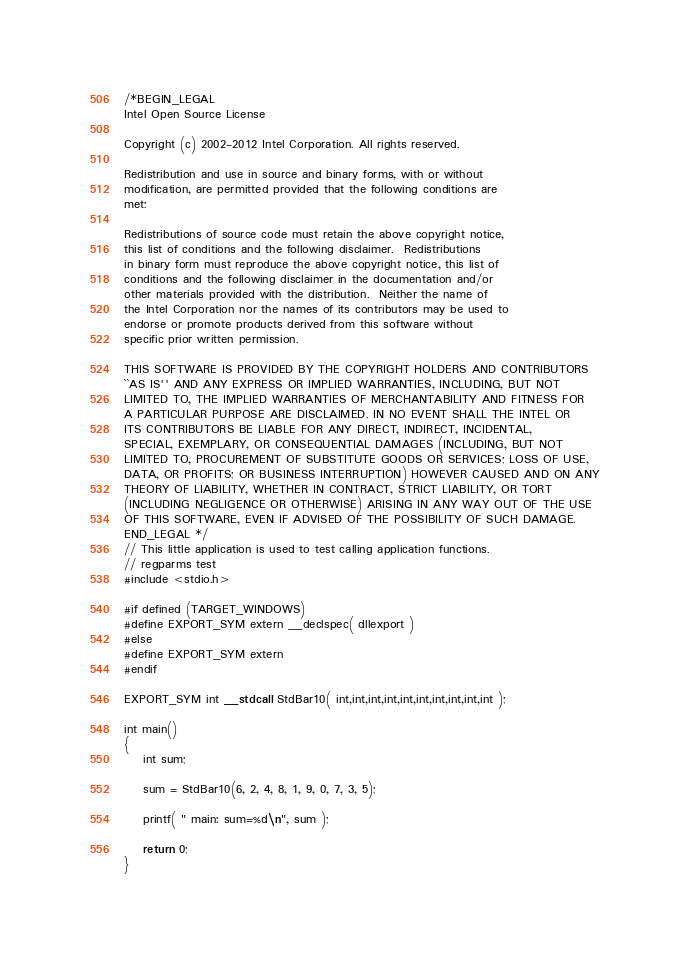Convert code to text. <code><loc_0><loc_0><loc_500><loc_500><_C_>/*BEGIN_LEGAL 
Intel Open Source License 

Copyright (c) 2002-2012 Intel Corporation. All rights reserved.
 
Redistribution and use in source and binary forms, with or without
modification, are permitted provided that the following conditions are
met:

Redistributions of source code must retain the above copyright notice,
this list of conditions and the following disclaimer.  Redistributions
in binary form must reproduce the above copyright notice, this list of
conditions and the following disclaimer in the documentation and/or
other materials provided with the distribution.  Neither the name of
the Intel Corporation nor the names of its contributors may be used to
endorse or promote products derived from this software without
specific prior written permission.
 
THIS SOFTWARE IS PROVIDED BY THE COPYRIGHT HOLDERS AND CONTRIBUTORS
``AS IS'' AND ANY EXPRESS OR IMPLIED WARRANTIES, INCLUDING, BUT NOT
LIMITED TO, THE IMPLIED WARRANTIES OF MERCHANTABILITY AND FITNESS FOR
A PARTICULAR PURPOSE ARE DISCLAIMED. IN NO EVENT SHALL THE INTEL OR
ITS CONTRIBUTORS BE LIABLE FOR ANY DIRECT, INDIRECT, INCIDENTAL,
SPECIAL, EXEMPLARY, OR CONSEQUENTIAL DAMAGES (INCLUDING, BUT NOT
LIMITED TO, PROCUREMENT OF SUBSTITUTE GOODS OR SERVICES; LOSS OF USE,
DATA, OR PROFITS; OR BUSINESS INTERRUPTION) HOWEVER CAUSED AND ON ANY
THEORY OF LIABILITY, WHETHER IN CONTRACT, STRICT LIABILITY, OR TORT
(INCLUDING NEGLIGENCE OR OTHERWISE) ARISING IN ANY WAY OUT OF THE USE
OF THIS SOFTWARE, EVEN IF ADVISED OF THE POSSIBILITY OF SUCH DAMAGE.
END_LEGAL */
// This little application is used to test calling application functions.
// regparms test
#include <stdio.h>

#if defined (TARGET_WINDOWS)
#define EXPORT_SYM extern __declspec( dllexport ) 
#else
#define EXPORT_SYM extern
#endif

EXPORT_SYM int __stdcall StdBar10( int,int,int,int,int,int,int,int,int,int );

int main()
{
	int sum;

    sum = StdBar10(6, 2, 4, 8, 1, 9, 0, 7, 3, 5);

	printf( " main: sum=%d\n", sum );

    return 0;
}
</code> 